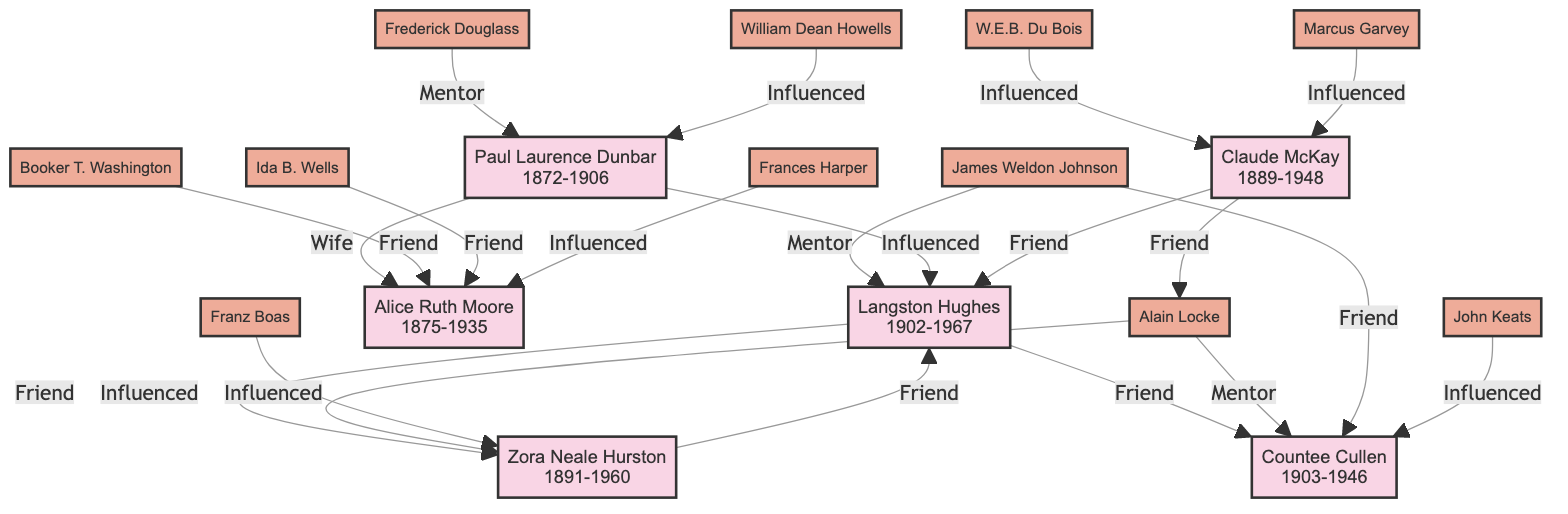What is the birth year of Langston Hughes? The diagram lists Langston Hughes as being born in 1902.
Answer: 1902 Who was the mentor of Countee Cullen? The diagram indicates that Alain Locke served as the mentor of Countee Cullen.
Answer: Alain Locke How many friends does Langston Hughes have according to the diagram? The diagram shows that Langston Hughes has two friends listed: Zora Neale Hurston and Countee Cullen. Therefore, the total number of friends is 2.
Answer: 2 What relationship does Paul Laurence Dunbar have with Alice Ruth Moore? In the diagram, Paul Laurence Dunbar is shown to have a "Wife" relationship with Alice Ruth Moore.
Answer: Wife Which poet influenced Claude McKay? The diagram shows that Claude McKay was influenced by W.E.B. Du Bois and Marcus Garvey. Since the question asks for the name of one, we can choose either.
Answer: W.E.B. Du Bois Which two poets are friends with Zora Neale Hurston? The diagram indicates that Zora Neale Hurston is friends with Langston Hughes and Sterling Brown.
Answer: Langston Hughes, Sterling Brown Count the total number of poets in the diagram. The diagram includes a total of six poets: Paul Laurence Dunbar, Langston Hughes, Claude McKay, Zora Neale Hurston, Countee Cullen, and Alice Ruth Moore. Therefore, the total number is 6.
Answer: 6 What is the connection between Langston Hughes and Paul Laurence Dunbar? The diagram shows that Paul Laurence Dunbar influenced Langston Hughes, establishing a direct relationship between them.
Answer: Influenced Who were the influences on Alice Ruth Moore? According to the diagram, Alice Ruth Moore was influenced by Frances Harper.
Answer: Frances Harper What type of relationship did Frederick Douglass have with Paul Laurence Dunbar? The diagram distinguishes Frederick Douglass as a mentor to Paul Laurence Dunbar.
Answer: Mentor 